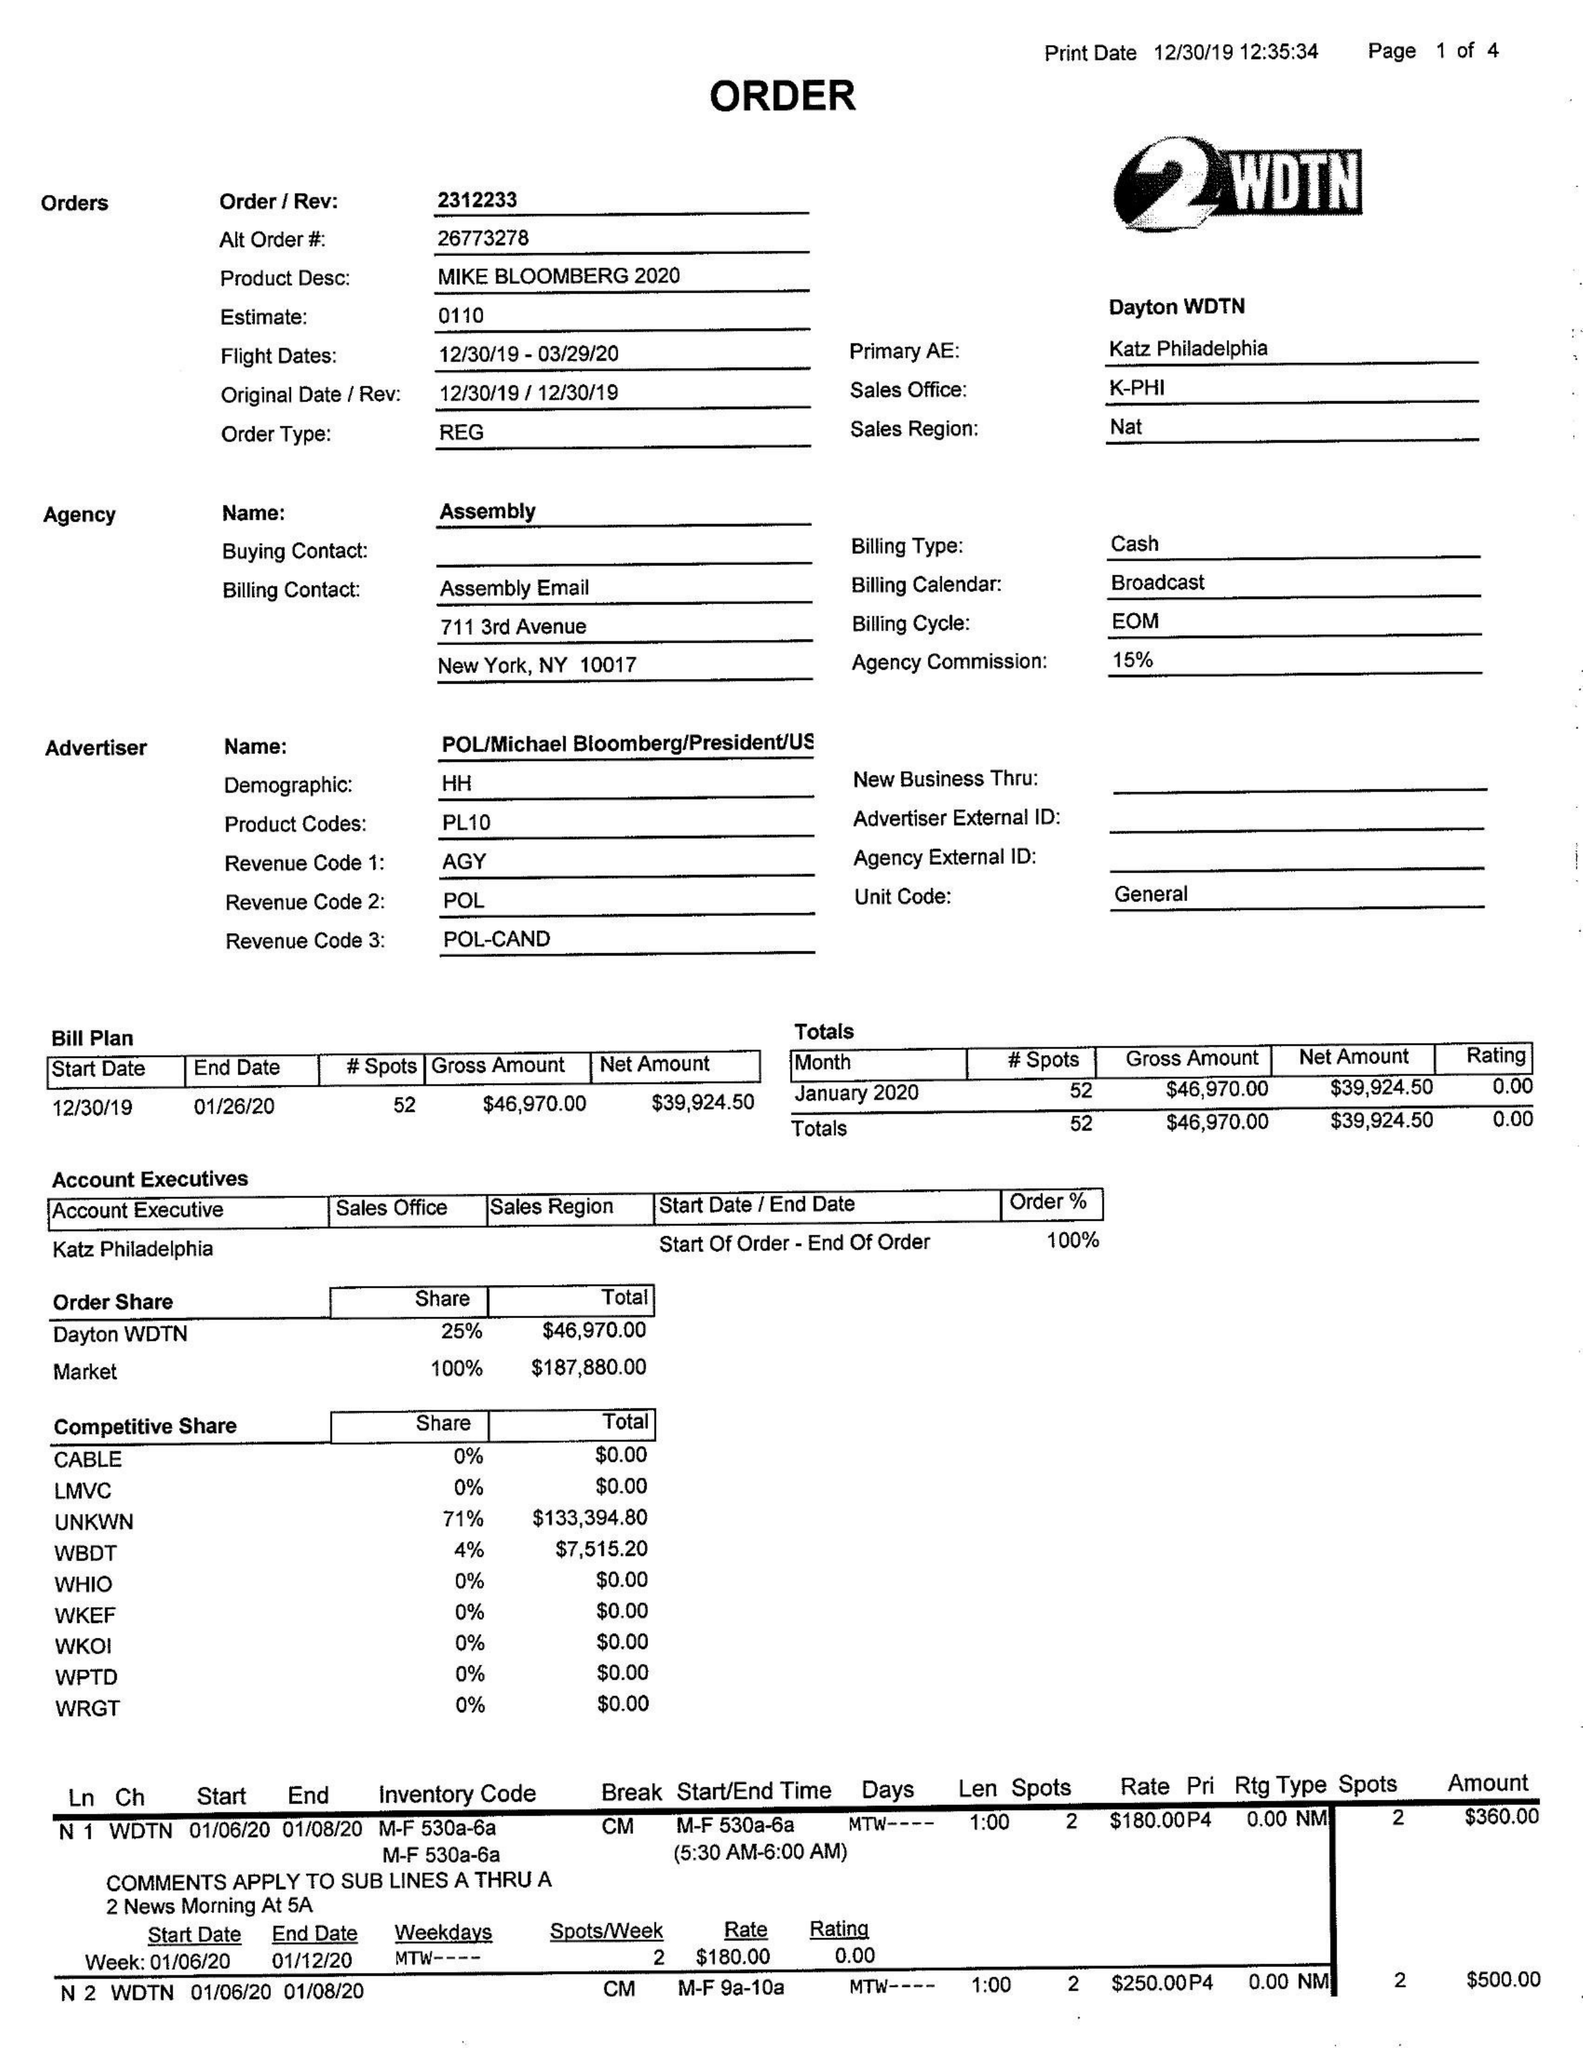What is the value for the flight_from?
Answer the question using a single word or phrase. 12/30/19 